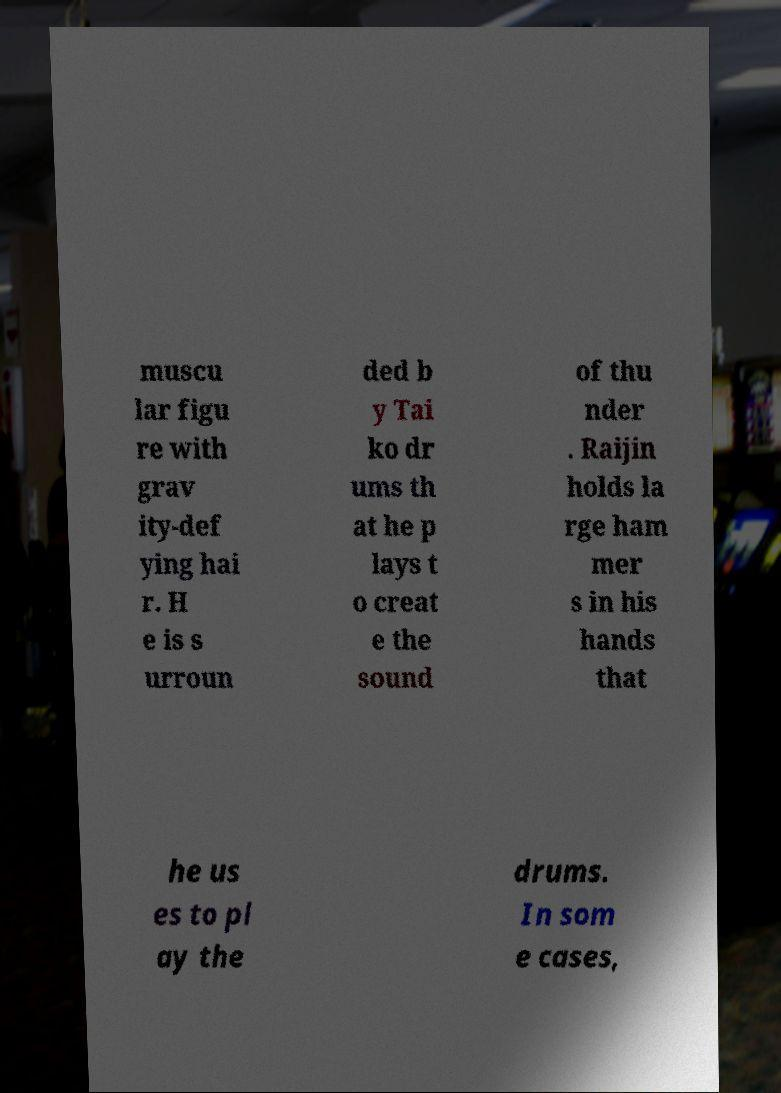Please identify and transcribe the text found in this image. muscu lar figu re with grav ity-def ying hai r. H e is s urroun ded b y Tai ko dr ums th at he p lays t o creat e the sound of thu nder . Raijin holds la rge ham mer s in his hands that he us es to pl ay the drums. In som e cases, 